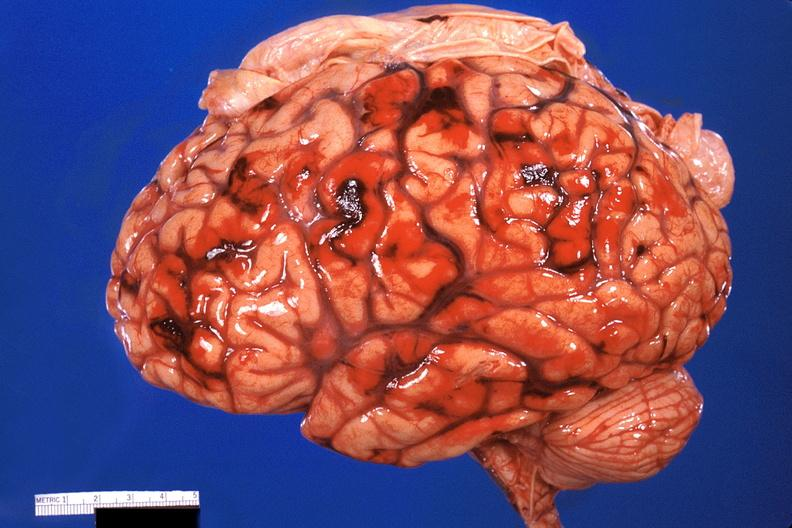does this image show brain, subarachanoid hemorrhage due to disseminated intravascular coagulation?
Answer the question using a single word or phrase. Yes 